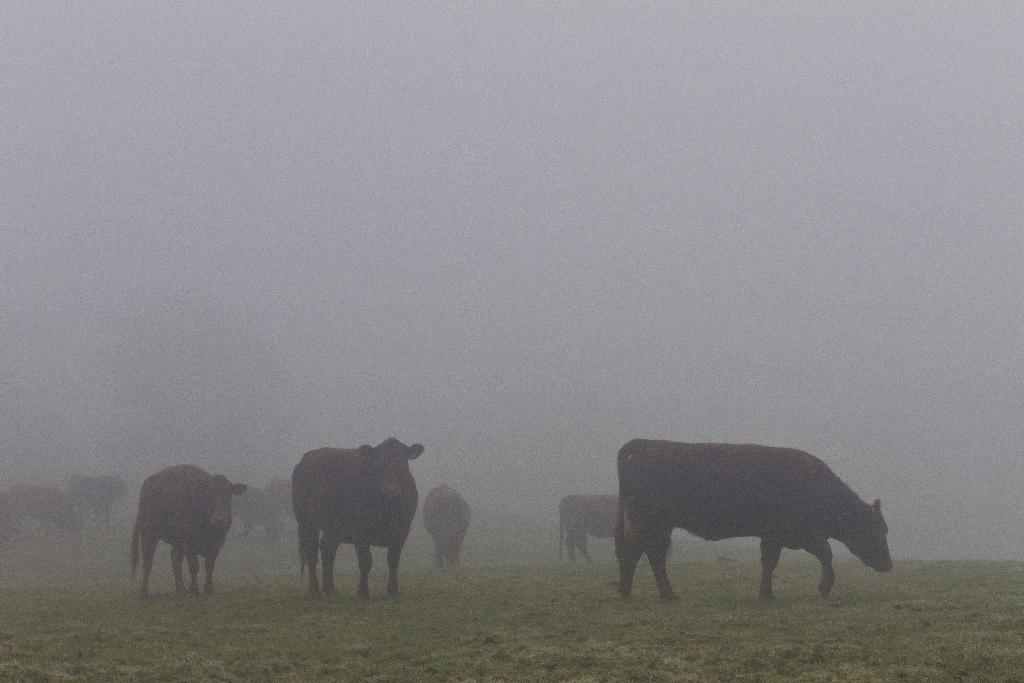What animals are present in the image? There is a group of cows in the image. Where are the cows located? The cows are in a grass field. What can be seen at the top of the image? The sky is visible at the top of the image. What type of silk is being spun by the cows in the image? There is no silk or spinning activity present in the image; it features a group of cows in a grass field. 